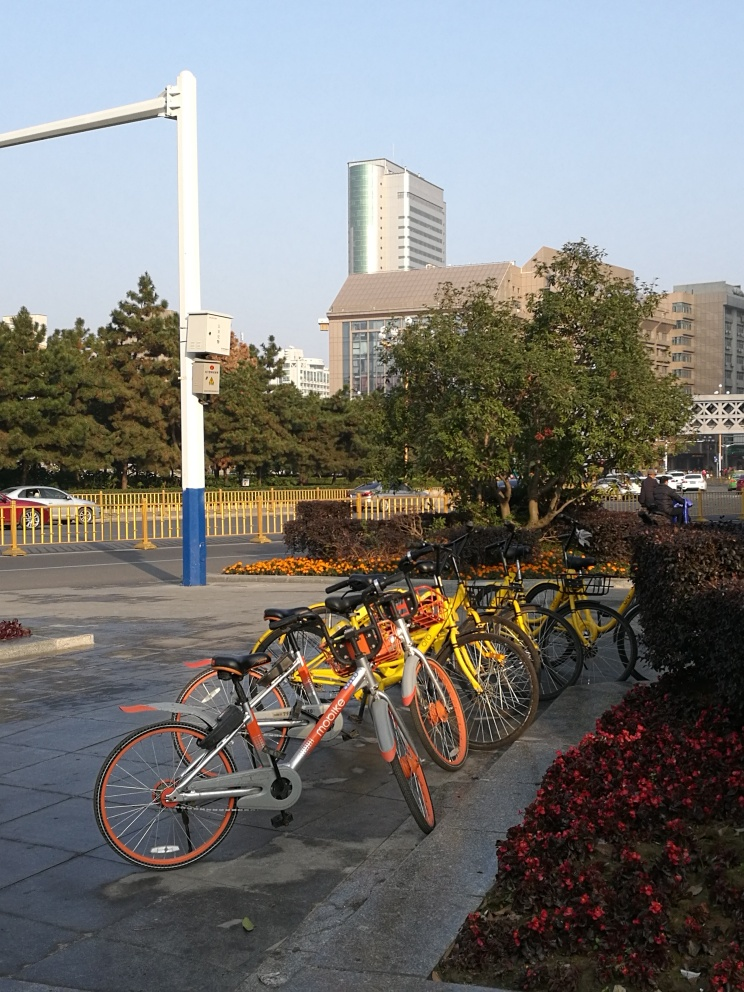What time of day does this photo seem to be taken at? Based on the length and position of the shadows in the image, as well as the quality of the sunlight, it appears to be taken in the late afternoon, when the sun is beginning to lower towards the horizon, casting longer shadows. 